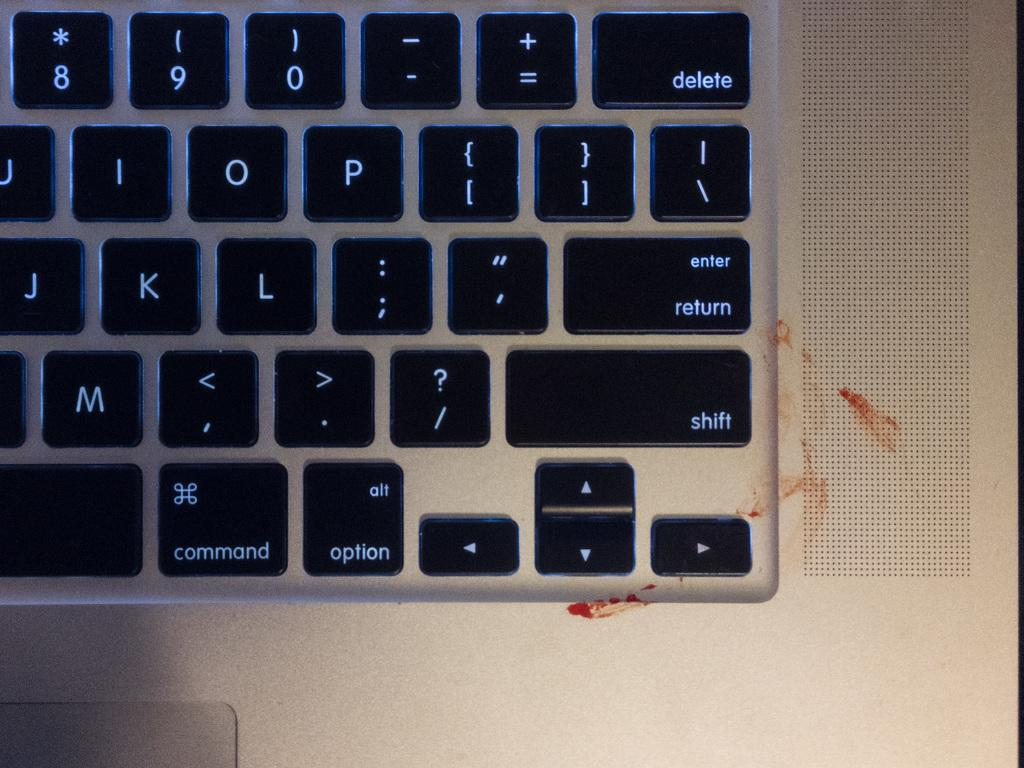<image>
Relay a brief, clear account of the picture shown. a keyboard with backlit keys including j k and l 